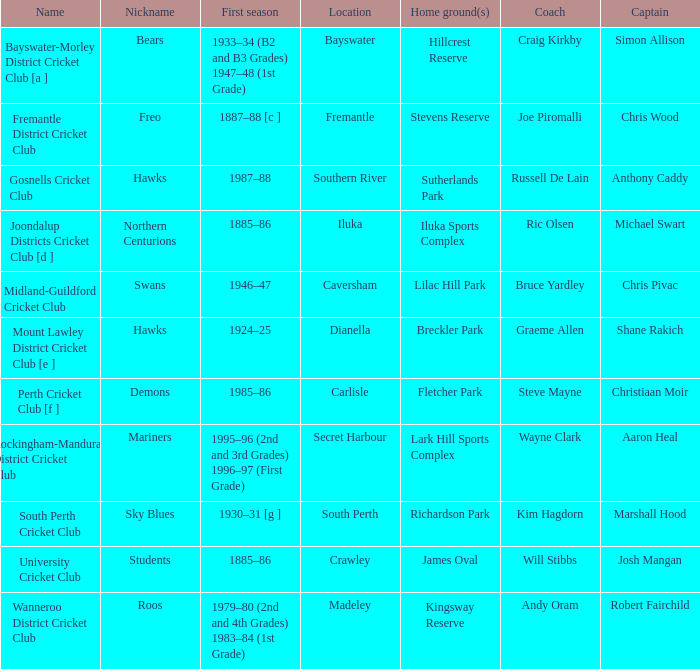With the nickname the swans, what is the home ground? Lilac Hill Park. 